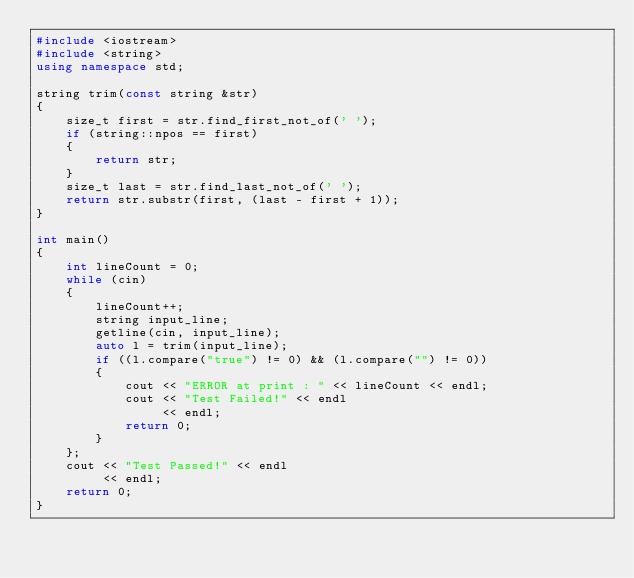Convert code to text. <code><loc_0><loc_0><loc_500><loc_500><_C++_>#include <iostream>
#include <string>
using namespace std;

string trim(const string &str)
{
    size_t first = str.find_first_not_of(' ');
    if (string::npos == first)
    {
        return str;
    }
    size_t last = str.find_last_not_of(' ');
    return str.substr(first, (last - first + 1));
}

int main()
{
    int lineCount = 0;
    while (cin)
    {
        lineCount++;
        string input_line;
        getline(cin, input_line);
        auto l = trim(input_line);
        if ((l.compare("true") != 0) && (l.compare("") != 0))
        {
            cout << "ERROR at print : " << lineCount << endl;
            cout << "Test Failed!" << endl
                 << endl;
            return 0;
        }
    };
    cout << "Test Passed!" << endl
         << endl;
    return 0;
}
</code> 